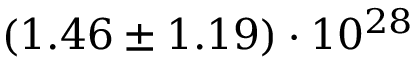<formula> <loc_0><loc_0><loc_500><loc_500>( 1 . 4 6 \pm 1 . 1 9 ) \cdot 1 0 ^ { 2 8 }</formula> 